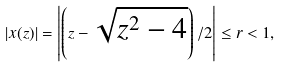Convert formula to latex. <formula><loc_0><loc_0><loc_500><loc_500>| x ( z ) | = \left | \left ( z - \sqrt { z ^ { 2 } - 4 } \right ) / 2 \right | \leq r < 1 ,</formula> 